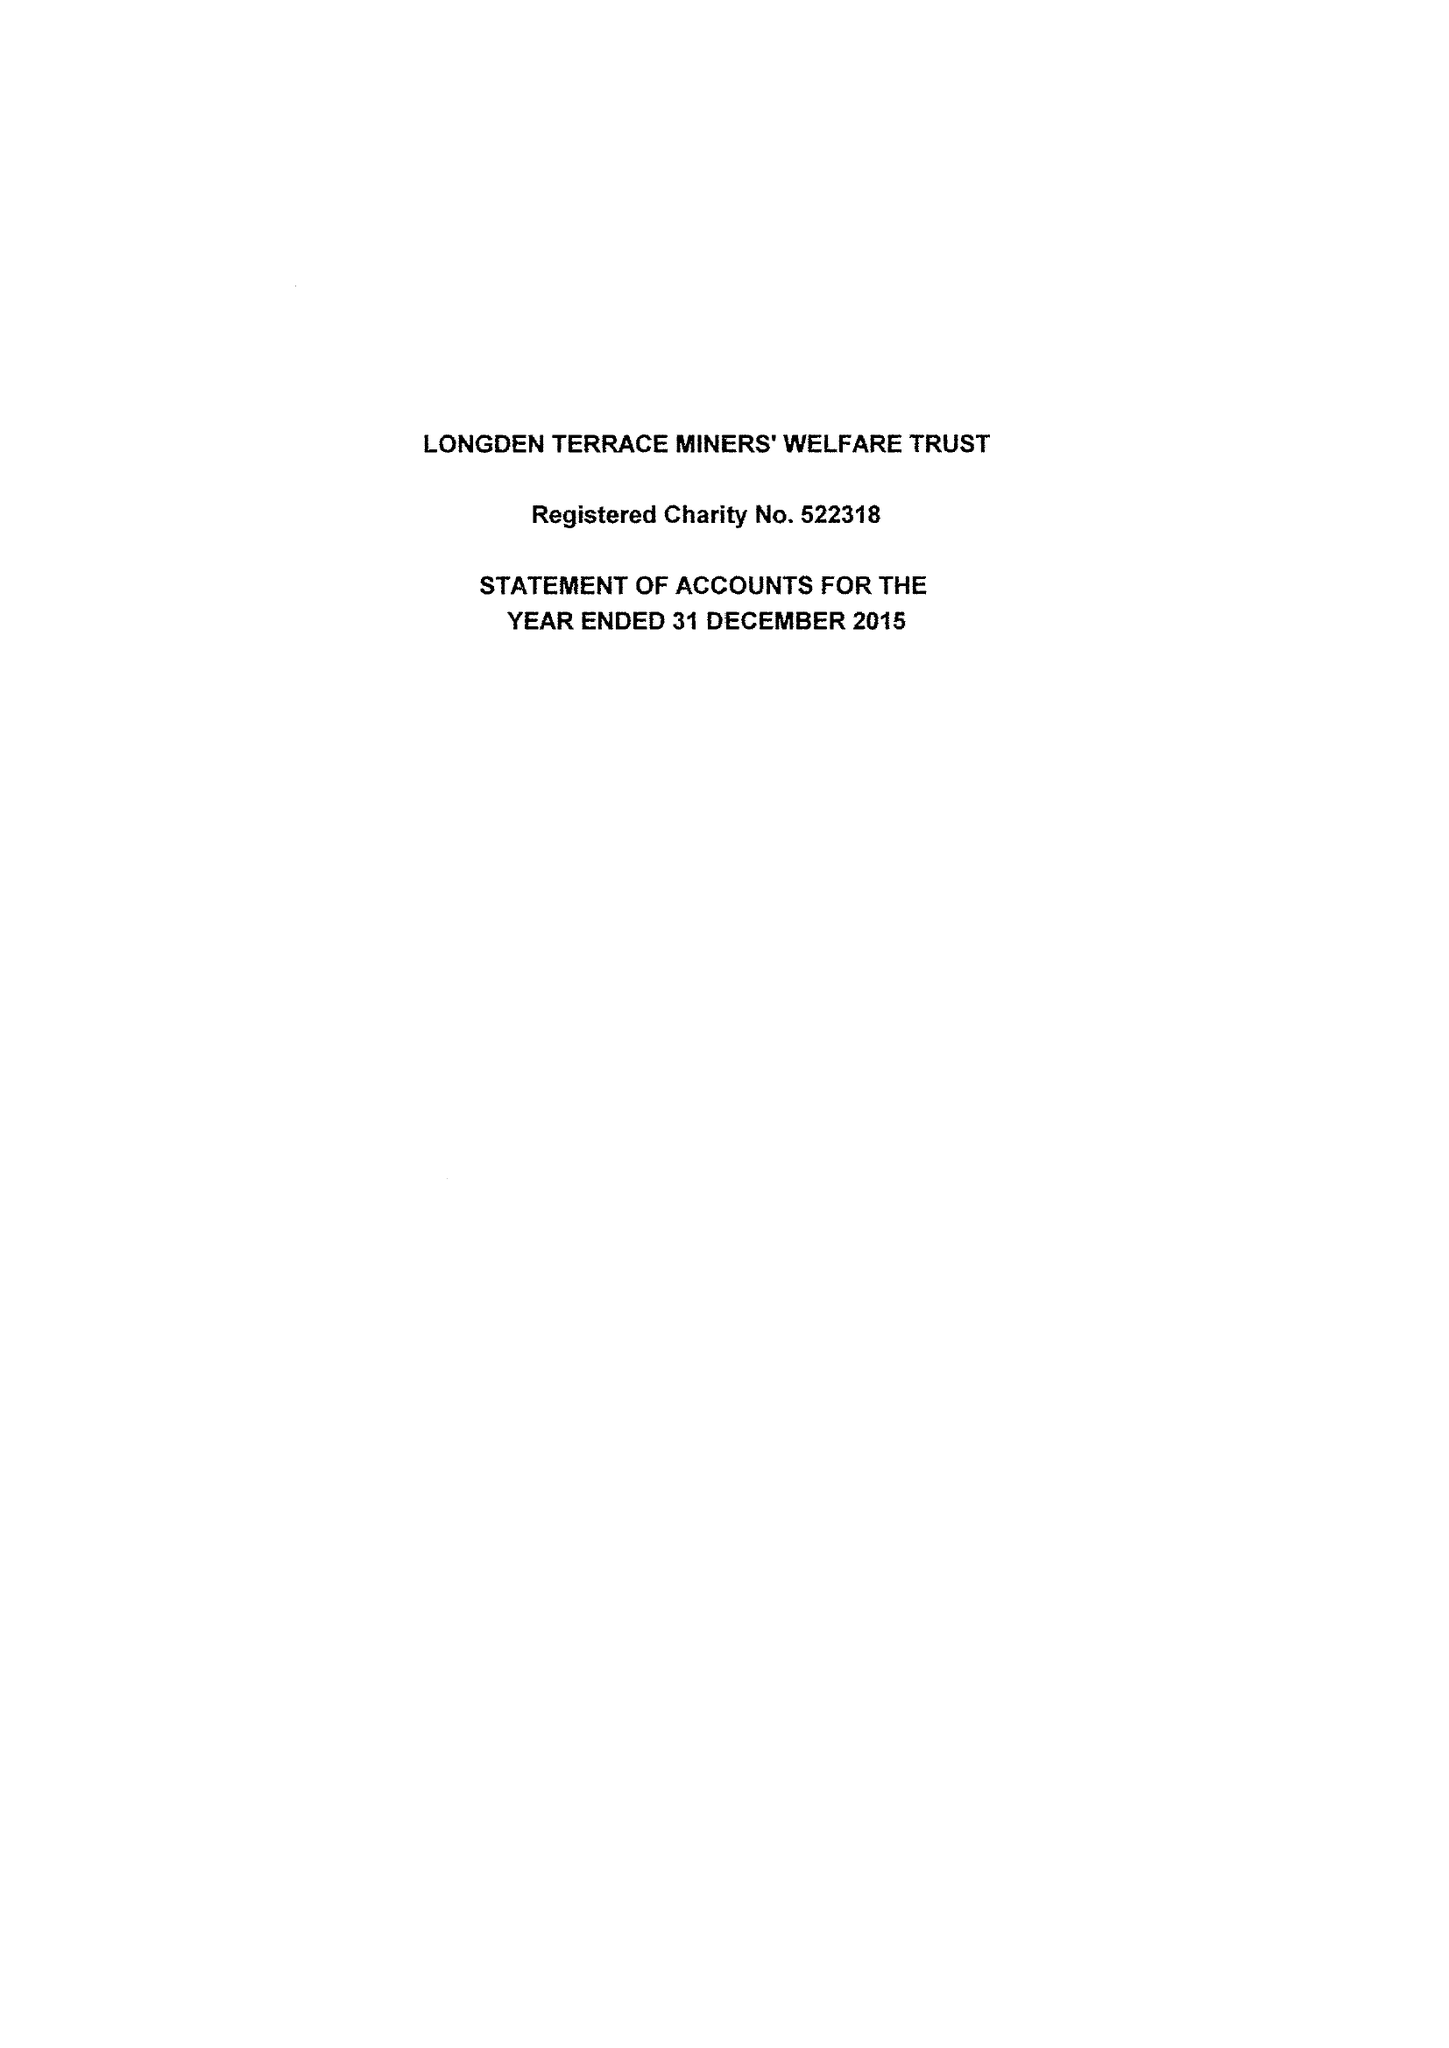What is the value for the address__street_line?
Answer the question using a single word or phrase. 8 BROCKLEHURST DRIVE 